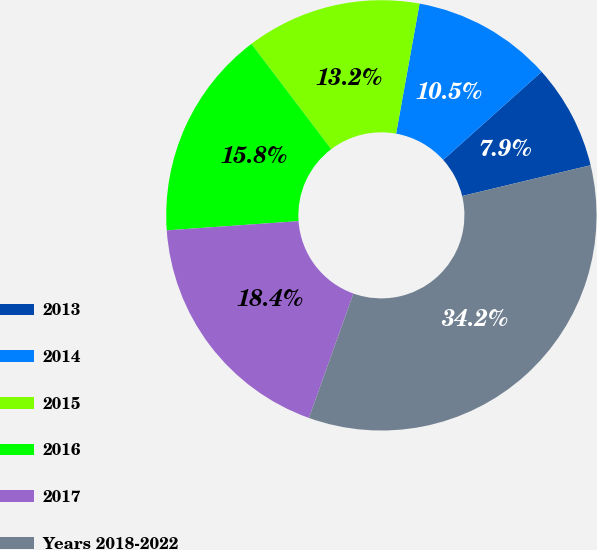Convert chart to OTSL. <chart><loc_0><loc_0><loc_500><loc_500><pie_chart><fcel>2013<fcel>2014<fcel>2015<fcel>2016<fcel>2017<fcel>Years 2018-2022<nl><fcel>7.89%<fcel>10.53%<fcel>13.16%<fcel>15.79%<fcel>18.42%<fcel>34.21%<nl></chart> 